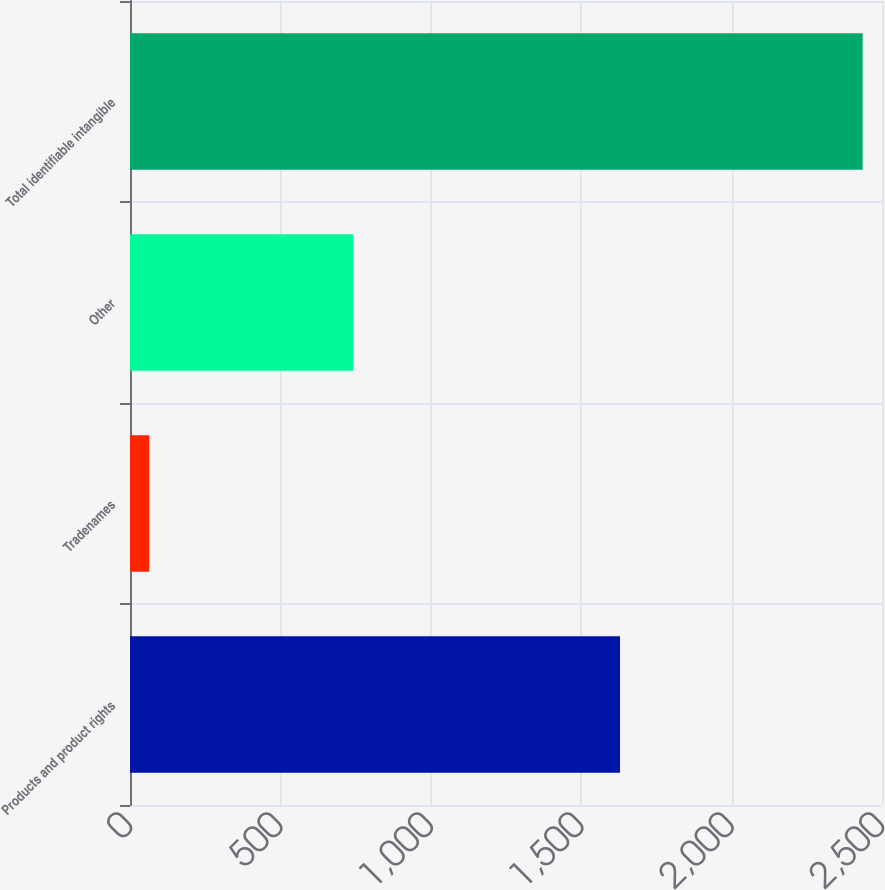<chart> <loc_0><loc_0><loc_500><loc_500><bar_chart><fcel>Products and product rights<fcel>Tradenames<fcel>Other<fcel>Total identifiable intangible<nl><fcel>1629.1<fcel>64<fcel>742.5<fcel>2435.6<nl></chart> 